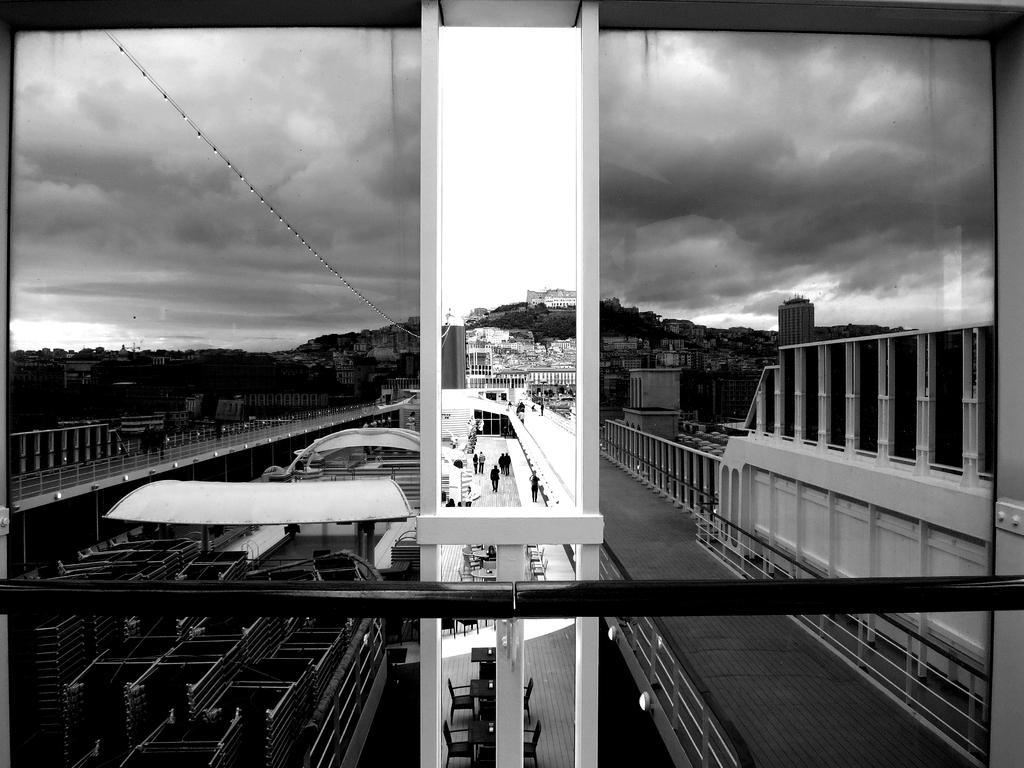How would you summarize this image in a sentence or two? Image is taken at the window of a ship. Where we can see loads on a boat, few sheds, tables, chairs, persons walking on the pavement and the lights. In the background, there are trees, buildings, sky and the cloud. 